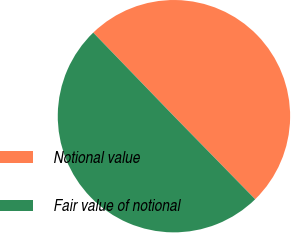<chart> <loc_0><loc_0><loc_500><loc_500><pie_chart><fcel>Notional value<fcel>Fair value of notional<nl><fcel>49.9%<fcel>50.1%<nl></chart> 